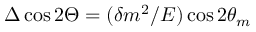Convert formula to latex. <formula><loc_0><loc_0><loc_500><loc_500>\Delta \cos 2 \Theta = ( \delta m ^ { 2 } / E ) \cos 2 \theta _ { m }</formula> 